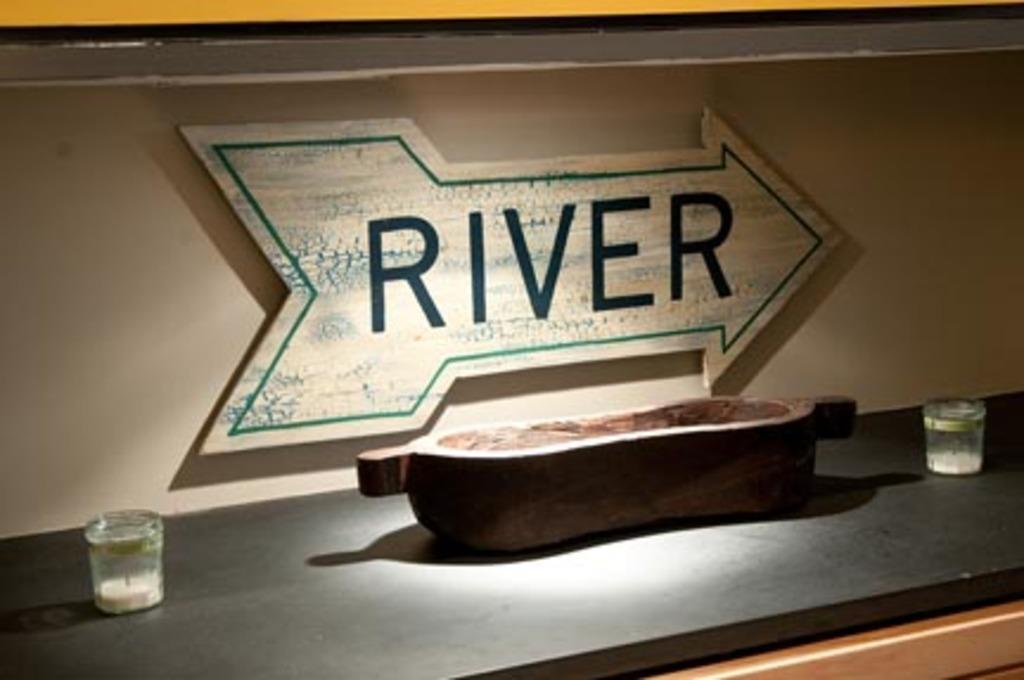What does the arrow say?
Give a very brief answer. River. What direction is the arrow pointed?
Offer a very short reply. Answering does not require reading text in the image. 